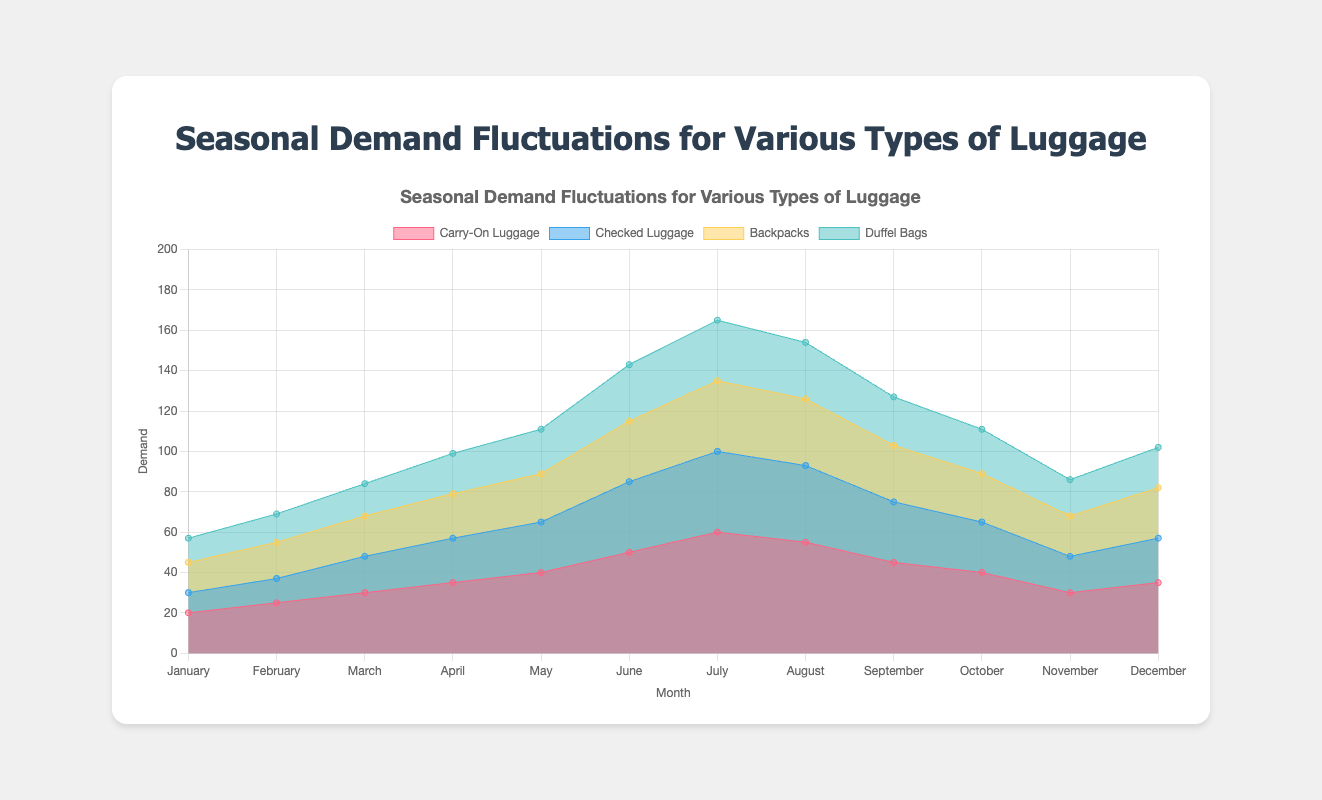What is the title of the chart? The title is usually displayed at the top of the chart. In this case, it is explicitly mentioned in the code.
Answer: Seasonal Demand Fluctuations for Various Types of Luggage Which type of luggage has the highest demand in July? By looking at the peak values for July in the dataset, carry-on luggage has the highest value of 60.
Answer: Carry-on luggage In which month does checked luggage have the lowest demand? By examining all values for checked luggage, January has the lowest value of 10.
Answer: January How does the demand for carry-on luggage in December compare to that in January? The demand for carry-on luggage in December is 35, whereas in January it is 20. Thus, the demand in December is 15 units higher than January.
Answer: 15 units higher What is the combined demand for backpacks and duffel bags in June? Adding the individual demands for June, backpacks (30) and duffel bags (28), results in a combined demand of 58.
Answer: 58 During which months is the demand for duffel bags higher than that for checked luggage? By comparing the monthly values of duffel bags and checked luggage, duffel bags have higher demand in January, February, and December.
Answer: January, February, December What is the average monthly demand for backpacks throughout the year? Summing up the monthly values for backpacks (15 + 18 + 20 + 22 + 24 + 30 + 35 + 33 + 28 + 24 + 20 + 25) and dividing by 12 results in an average of 24.58.
Answer: 24.58 Which month shows the highest total demand across all types of luggage? Summing the demands for all types in each month, July has the highest total: 60 (carry-on) + 40 (checked) + 35 (backpacks) + 30 (duffel) = 165.
Answer: July What pattern do you observe in the demand for checked luggage from January to December? The demand for checked luggage begins low in January, gradually increases until July, then decreases towards December, indicating a seasonal pattern.
Answer: Seasonal increase and decrease How does the demand for carry-on luggage in August compare to its demand in September? In August, the demand is 55, while in September it decreases to 45. Therefore, the demand drops by 10 units from August to September.
Answer: Drops by 10 